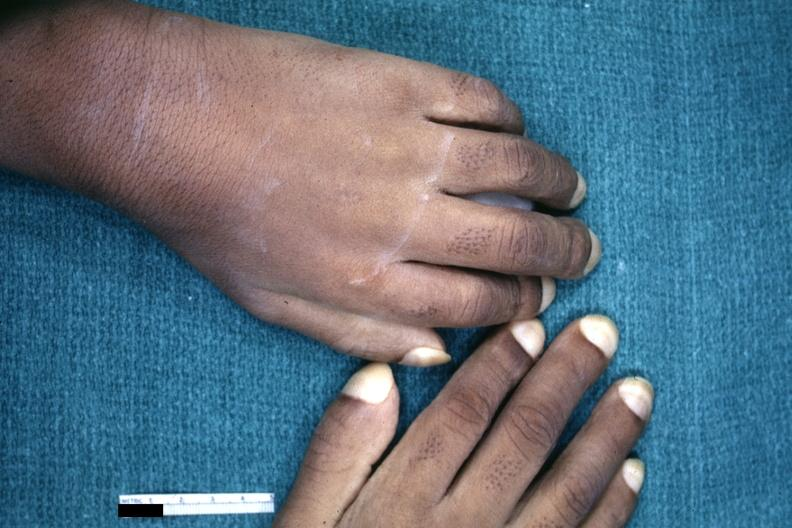s pulmonary osteoarthropathy present?
Answer the question using a single word or phrase. Yes 